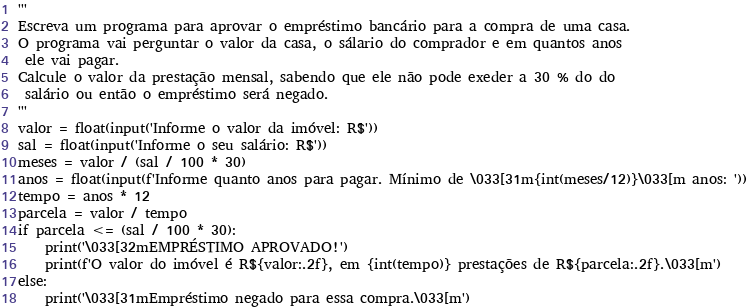<code> <loc_0><loc_0><loc_500><loc_500><_Python_>'''
Escreva um programa para aprovar o empréstimo bancário para a compra de uma casa.
O programa vai perguntar o valor da casa, o sálario do comprador e em quantos anos
 ele vai pagar.
Calcule o valor da prestação mensal, sabendo que ele não pode exeder a 30 % do do
 salário ou então o empréstimo será negado.
'''
valor = float(input('Informe o valor da imóvel: R$'))
sal = float(input('Informe o seu salário: R$'))
meses = valor / (sal / 100 * 30)
anos = float(input(f'Informe quanto anos para pagar. Mínimo de \033[31m{int(meses/12)}\033[m anos: '))
tempo = anos * 12
parcela = valor / tempo
if parcela <= (sal / 100 * 30):
    print('\033[32mEMPRÉSTIMO APROVADO!')
    print(f'O valor do imóvel é R${valor:.2f}, em {int(tempo)} prestações de R${parcela:.2f}.\033[m')
else:
    print('\033[31mEmpréstimo negado para essa compra.\033[m')</code> 